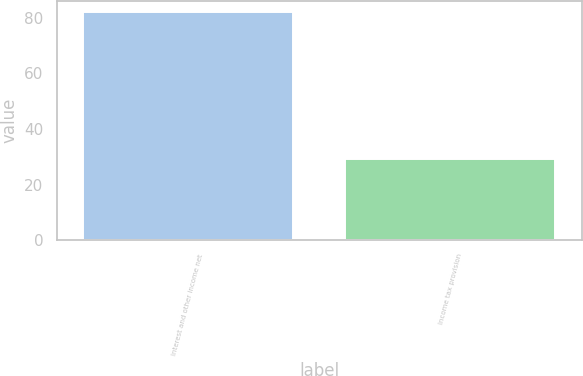<chart> <loc_0><loc_0><loc_500><loc_500><bar_chart><fcel>Interest and other income net<fcel>Income tax provision<nl><fcel>82<fcel>29<nl></chart> 